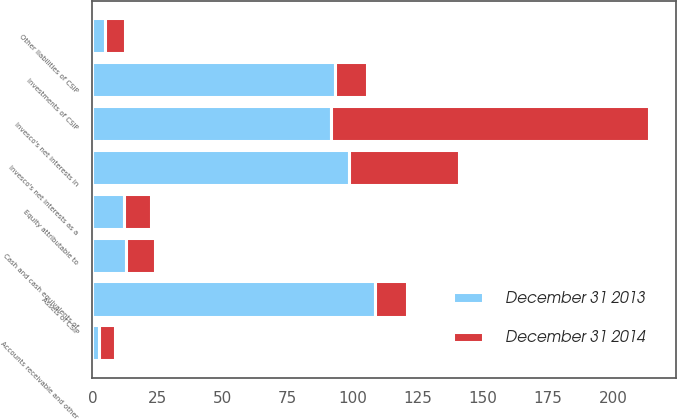<chart> <loc_0><loc_0><loc_500><loc_500><stacked_bar_chart><ecel><fcel>Investments of CSIP<fcel>Cash and cash equivalents of<fcel>Accounts receivable and other<fcel>Assets of CSIP<fcel>Other liabilities of CSIP<fcel>Equity attributable to<fcel>Invesco's net interests in<fcel>Invesco's net interests as a<nl><fcel>December 31 2014<fcel>12.35<fcel>11.4<fcel>5.9<fcel>12.35<fcel>7.9<fcel>10.6<fcel>121.8<fcel>42.2<nl><fcel>December 31 2013<fcel>93.2<fcel>12.7<fcel>2.6<fcel>108.5<fcel>4.7<fcel>12<fcel>91.8<fcel>98.5<nl></chart> 